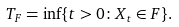Convert formula to latex. <formula><loc_0><loc_0><loc_500><loc_500>T _ { F } = \inf \{ t > 0 \colon X _ { t } \in F \} .</formula> 